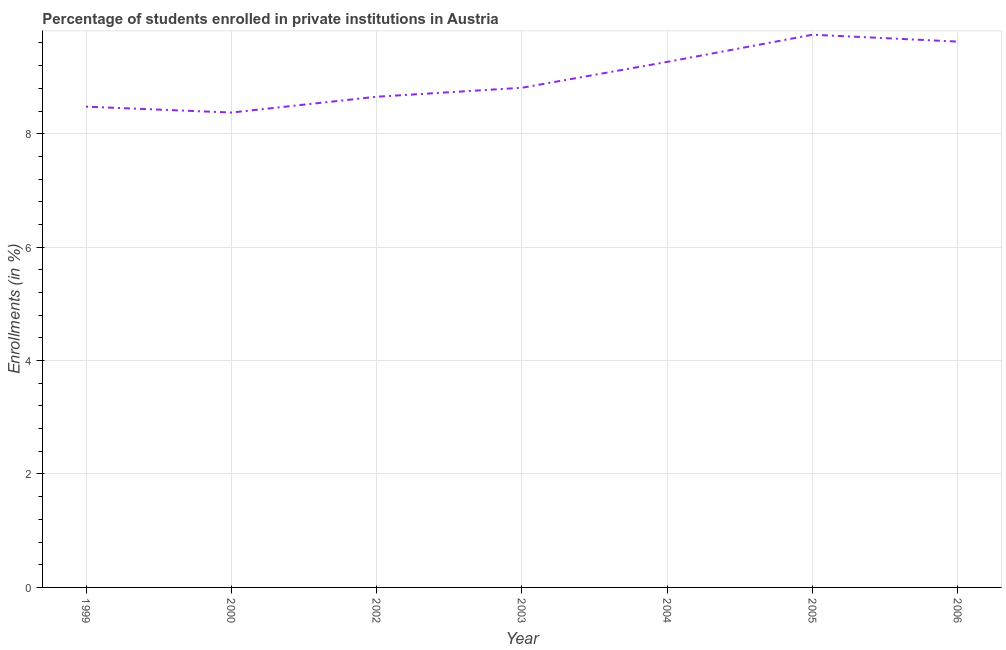What is the enrollments in private institutions in 2002?
Offer a terse response. 8.65. Across all years, what is the maximum enrollments in private institutions?
Your response must be concise. 9.75. Across all years, what is the minimum enrollments in private institutions?
Your response must be concise. 8.37. In which year was the enrollments in private institutions minimum?
Your answer should be compact. 2000. What is the sum of the enrollments in private institutions?
Your answer should be compact. 62.95. What is the difference between the enrollments in private institutions in 2003 and 2004?
Offer a terse response. -0.46. What is the average enrollments in private institutions per year?
Your response must be concise. 8.99. What is the median enrollments in private institutions?
Your answer should be very brief. 8.81. Do a majority of the years between 1999 and 2003 (inclusive) have enrollments in private institutions greater than 3.2 %?
Provide a succinct answer. Yes. What is the ratio of the enrollments in private institutions in 2005 to that in 2006?
Offer a terse response. 1.01. What is the difference between the highest and the second highest enrollments in private institutions?
Give a very brief answer. 0.12. What is the difference between the highest and the lowest enrollments in private institutions?
Provide a succinct answer. 1.37. In how many years, is the enrollments in private institutions greater than the average enrollments in private institutions taken over all years?
Give a very brief answer. 3. Does the enrollments in private institutions monotonically increase over the years?
Offer a very short reply. No. How many lines are there?
Provide a succinct answer. 1. How many years are there in the graph?
Your response must be concise. 7. Does the graph contain any zero values?
Your answer should be compact. No. Does the graph contain grids?
Your answer should be compact. Yes. What is the title of the graph?
Ensure brevity in your answer.  Percentage of students enrolled in private institutions in Austria. What is the label or title of the Y-axis?
Your answer should be very brief. Enrollments (in %). What is the Enrollments (in %) of 1999?
Make the answer very short. 8.48. What is the Enrollments (in %) in 2000?
Provide a succinct answer. 8.37. What is the Enrollments (in %) of 2002?
Provide a succinct answer. 8.65. What is the Enrollments (in %) of 2003?
Your response must be concise. 8.81. What is the Enrollments (in %) in 2004?
Make the answer very short. 9.27. What is the Enrollments (in %) in 2005?
Give a very brief answer. 9.75. What is the Enrollments (in %) of 2006?
Your response must be concise. 9.62. What is the difference between the Enrollments (in %) in 1999 and 2000?
Provide a succinct answer. 0.1. What is the difference between the Enrollments (in %) in 1999 and 2002?
Your response must be concise. -0.18. What is the difference between the Enrollments (in %) in 1999 and 2003?
Provide a short and direct response. -0.33. What is the difference between the Enrollments (in %) in 1999 and 2004?
Ensure brevity in your answer.  -0.79. What is the difference between the Enrollments (in %) in 1999 and 2005?
Give a very brief answer. -1.27. What is the difference between the Enrollments (in %) in 1999 and 2006?
Your answer should be compact. -1.15. What is the difference between the Enrollments (in %) in 2000 and 2002?
Your answer should be very brief. -0.28. What is the difference between the Enrollments (in %) in 2000 and 2003?
Your answer should be compact. -0.44. What is the difference between the Enrollments (in %) in 2000 and 2004?
Ensure brevity in your answer.  -0.89. What is the difference between the Enrollments (in %) in 2000 and 2005?
Provide a succinct answer. -1.37. What is the difference between the Enrollments (in %) in 2000 and 2006?
Offer a very short reply. -1.25. What is the difference between the Enrollments (in %) in 2002 and 2003?
Give a very brief answer. -0.16. What is the difference between the Enrollments (in %) in 2002 and 2004?
Offer a very short reply. -0.61. What is the difference between the Enrollments (in %) in 2002 and 2005?
Your answer should be very brief. -1.09. What is the difference between the Enrollments (in %) in 2002 and 2006?
Provide a short and direct response. -0.97. What is the difference between the Enrollments (in %) in 2003 and 2004?
Provide a short and direct response. -0.46. What is the difference between the Enrollments (in %) in 2003 and 2005?
Offer a terse response. -0.94. What is the difference between the Enrollments (in %) in 2003 and 2006?
Provide a succinct answer. -0.81. What is the difference between the Enrollments (in %) in 2004 and 2005?
Ensure brevity in your answer.  -0.48. What is the difference between the Enrollments (in %) in 2004 and 2006?
Your answer should be compact. -0.36. What is the difference between the Enrollments (in %) in 2005 and 2006?
Ensure brevity in your answer.  0.12. What is the ratio of the Enrollments (in %) in 1999 to that in 2002?
Keep it short and to the point. 0.98. What is the ratio of the Enrollments (in %) in 1999 to that in 2003?
Keep it short and to the point. 0.96. What is the ratio of the Enrollments (in %) in 1999 to that in 2004?
Make the answer very short. 0.92. What is the ratio of the Enrollments (in %) in 1999 to that in 2005?
Your answer should be compact. 0.87. What is the ratio of the Enrollments (in %) in 1999 to that in 2006?
Your answer should be compact. 0.88. What is the ratio of the Enrollments (in %) in 2000 to that in 2004?
Keep it short and to the point. 0.9. What is the ratio of the Enrollments (in %) in 2000 to that in 2005?
Ensure brevity in your answer.  0.86. What is the ratio of the Enrollments (in %) in 2000 to that in 2006?
Offer a very short reply. 0.87. What is the ratio of the Enrollments (in %) in 2002 to that in 2004?
Provide a short and direct response. 0.93. What is the ratio of the Enrollments (in %) in 2002 to that in 2005?
Your answer should be compact. 0.89. What is the ratio of the Enrollments (in %) in 2002 to that in 2006?
Your answer should be very brief. 0.9. What is the ratio of the Enrollments (in %) in 2003 to that in 2004?
Make the answer very short. 0.95. What is the ratio of the Enrollments (in %) in 2003 to that in 2005?
Offer a terse response. 0.9. What is the ratio of the Enrollments (in %) in 2003 to that in 2006?
Provide a short and direct response. 0.92. What is the ratio of the Enrollments (in %) in 2004 to that in 2005?
Keep it short and to the point. 0.95. What is the ratio of the Enrollments (in %) in 2004 to that in 2006?
Your response must be concise. 0.96. 